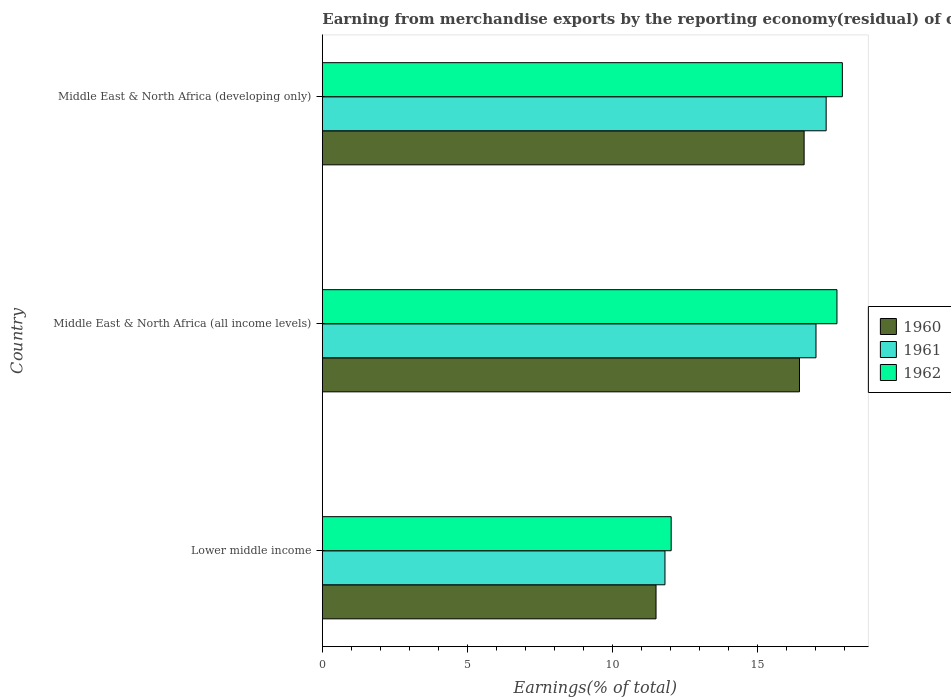How many different coloured bars are there?
Ensure brevity in your answer.  3. Are the number of bars per tick equal to the number of legend labels?
Your answer should be very brief. Yes. Are the number of bars on each tick of the Y-axis equal?
Keep it short and to the point. Yes. How many bars are there on the 2nd tick from the top?
Your answer should be very brief. 3. How many bars are there on the 3rd tick from the bottom?
Ensure brevity in your answer.  3. What is the label of the 3rd group of bars from the top?
Ensure brevity in your answer.  Lower middle income. In how many cases, is the number of bars for a given country not equal to the number of legend labels?
Your response must be concise. 0. What is the percentage of amount earned from merchandise exports in 1962 in Lower middle income?
Keep it short and to the point. 12.02. Across all countries, what is the maximum percentage of amount earned from merchandise exports in 1962?
Provide a short and direct response. 17.93. Across all countries, what is the minimum percentage of amount earned from merchandise exports in 1961?
Your answer should be very brief. 11.81. In which country was the percentage of amount earned from merchandise exports in 1962 maximum?
Your answer should be compact. Middle East & North Africa (developing only). In which country was the percentage of amount earned from merchandise exports in 1961 minimum?
Keep it short and to the point. Lower middle income. What is the total percentage of amount earned from merchandise exports in 1961 in the graph?
Ensure brevity in your answer.  46.19. What is the difference between the percentage of amount earned from merchandise exports in 1961 in Middle East & North Africa (all income levels) and that in Middle East & North Africa (developing only)?
Provide a short and direct response. -0.35. What is the difference between the percentage of amount earned from merchandise exports in 1960 in Lower middle income and the percentage of amount earned from merchandise exports in 1962 in Middle East & North Africa (all income levels)?
Provide a succinct answer. -6.24. What is the average percentage of amount earned from merchandise exports in 1960 per country?
Offer a very short reply. 14.85. What is the difference between the percentage of amount earned from merchandise exports in 1960 and percentage of amount earned from merchandise exports in 1962 in Middle East & North Africa (developing only)?
Offer a very short reply. -1.32. In how many countries, is the percentage of amount earned from merchandise exports in 1962 greater than 11 %?
Give a very brief answer. 3. What is the ratio of the percentage of amount earned from merchandise exports in 1962 in Middle East & North Africa (all income levels) to that in Middle East & North Africa (developing only)?
Offer a very short reply. 0.99. Is the difference between the percentage of amount earned from merchandise exports in 1960 in Middle East & North Africa (all income levels) and Middle East & North Africa (developing only) greater than the difference between the percentage of amount earned from merchandise exports in 1962 in Middle East & North Africa (all income levels) and Middle East & North Africa (developing only)?
Your response must be concise. Yes. What is the difference between the highest and the second highest percentage of amount earned from merchandise exports in 1961?
Your response must be concise. 0.35. What is the difference between the highest and the lowest percentage of amount earned from merchandise exports in 1961?
Give a very brief answer. 5.56. In how many countries, is the percentage of amount earned from merchandise exports in 1961 greater than the average percentage of amount earned from merchandise exports in 1961 taken over all countries?
Make the answer very short. 2. Is the sum of the percentage of amount earned from merchandise exports in 1961 in Lower middle income and Middle East & North Africa (developing only) greater than the maximum percentage of amount earned from merchandise exports in 1960 across all countries?
Keep it short and to the point. Yes. Is it the case that in every country, the sum of the percentage of amount earned from merchandise exports in 1961 and percentage of amount earned from merchandise exports in 1960 is greater than the percentage of amount earned from merchandise exports in 1962?
Your answer should be compact. Yes. Are all the bars in the graph horizontal?
Give a very brief answer. Yes. Are the values on the major ticks of X-axis written in scientific E-notation?
Offer a terse response. No. Where does the legend appear in the graph?
Give a very brief answer. Center right. What is the title of the graph?
Your answer should be compact. Earning from merchandise exports by the reporting economy(residual) of countries. Does "1989" appear as one of the legend labels in the graph?
Ensure brevity in your answer.  No. What is the label or title of the X-axis?
Your response must be concise. Earnings(% of total). What is the Earnings(% of total) of 1960 in Lower middle income?
Make the answer very short. 11.5. What is the Earnings(% of total) of 1961 in Lower middle income?
Ensure brevity in your answer.  11.81. What is the Earnings(% of total) of 1962 in Lower middle income?
Your response must be concise. 12.02. What is the Earnings(% of total) of 1960 in Middle East & North Africa (all income levels)?
Ensure brevity in your answer.  16.45. What is the Earnings(% of total) of 1961 in Middle East & North Africa (all income levels)?
Give a very brief answer. 17.02. What is the Earnings(% of total) in 1962 in Middle East & North Africa (all income levels)?
Keep it short and to the point. 17.74. What is the Earnings(% of total) in 1960 in Middle East & North Africa (developing only)?
Your answer should be compact. 16.61. What is the Earnings(% of total) in 1961 in Middle East & North Africa (developing only)?
Provide a succinct answer. 17.37. What is the Earnings(% of total) in 1962 in Middle East & North Africa (developing only)?
Your answer should be very brief. 17.93. Across all countries, what is the maximum Earnings(% of total) of 1960?
Your response must be concise. 16.61. Across all countries, what is the maximum Earnings(% of total) in 1961?
Your answer should be very brief. 17.37. Across all countries, what is the maximum Earnings(% of total) in 1962?
Ensure brevity in your answer.  17.93. Across all countries, what is the minimum Earnings(% of total) of 1960?
Offer a very short reply. 11.5. Across all countries, what is the minimum Earnings(% of total) in 1961?
Your answer should be very brief. 11.81. Across all countries, what is the minimum Earnings(% of total) of 1962?
Your answer should be very brief. 12.02. What is the total Earnings(% of total) in 1960 in the graph?
Provide a short and direct response. 44.56. What is the total Earnings(% of total) of 1961 in the graph?
Make the answer very short. 46.19. What is the total Earnings(% of total) in 1962 in the graph?
Give a very brief answer. 47.69. What is the difference between the Earnings(% of total) in 1960 in Lower middle income and that in Middle East & North Africa (all income levels)?
Offer a very short reply. -4.94. What is the difference between the Earnings(% of total) in 1961 in Lower middle income and that in Middle East & North Africa (all income levels)?
Your answer should be very brief. -5.21. What is the difference between the Earnings(% of total) of 1962 in Lower middle income and that in Middle East & North Africa (all income levels)?
Offer a very short reply. -5.71. What is the difference between the Earnings(% of total) in 1960 in Lower middle income and that in Middle East & North Africa (developing only)?
Offer a very short reply. -5.1. What is the difference between the Earnings(% of total) in 1961 in Lower middle income and that in Middle East & North Africa (developing only)?
Keep it short and to the point. -5.56. What is the difference between the Earnings(% of total) of 1962 in Lower middle income and that in Middle East & North Africa (developing only)?
Provide a succinct answer. -5.9. What is the difference between the Earnings(% of total) of 1960 in Middle East & North Africa (all income levels) and that in Middle East & North Africa (developing only)?
Keep it short and to the point. -0.16. What is the difference between the Earnings(% of total) of 1961 in Middle East & North Africa (all income levels) and that in Middle East & North Africa (developing only)?
Your response must be concise. -0.35. What is the difference between the Earnings(% of total) of 1962 in Middle East & North Africa (all income levels) and that in Middle East & North Africa (developing only)?
Your answer should be very brief. -0.19. What is the difference between the Earnings(% of total) in 1960 in Lower middle income and the Earnings(% of total) in 1961 in Middle East & North Africa (all income levels)?
Your answer should be compact. -5.51. What is the difference between the Earnings(% of total) of 1960 in Lower middle income and the Earnings(% of total) of 1962 in Middle East & North Africa (all income levels)?
Provide a short and direct response. -6.24. What is the difference between the Earnings(% of total) of 1961 in Lower middle income and the Earnings(% of total) of 1962 in Middle East & North Africa (all income levels)?
Ensure brevity in your answer.  -5.93. What is the difference between the Earnings(% of total) in 1960 in Lower middle income and the Earnings(% of total) in 1961 in Middle East & North Africa (developing only)?
Your answer should be very brief. -5.86. What is the difference between the Earnings(% of total) of 1960 in Lower middle income and the Earnings(% of total) of 1962 in Middle East & North Africa (developing only)?
Your response must be concise. -6.42. What is the difference between the Earnings(% of total) of 1961 in Lower middle income and the Earnings(% of total) of 1962 in Middle East & North Africa (developing only)?
Your response must be concise. -6.11. What is the difference between the Earnings(% of total) in 1960 in Middle East & North Africa (all income levels) and the Earnings(% of total) in 1961 in Middle East & North Africa (developing only)?
Provide a short and direct response. -0.92. What is the difference between the Earnings(% of total) in 1960 in Middle East & North Africa (all income levels) and the Earnings(% of total) in 1962 in Middle East & North Africa (developing only)?
Your answer should be compact. -1.48. What is the difference between the Earnings(% of total) of 1961 in Middle East & North Africa (all income levels) and the Earnings(% of total) of 1962 in Middle East & North Africa (developing only)?
Offer a very short reply. -0.91. What is the average Earnings(% of total) in 1960 per country?
Offer a terse response. 14.85. What is the average Earnings(% of total) in 1961 per country?
Your answer should be compact. 15.4. What is the average Earnings(% of total) of 1962 per country?
Offer a terse response. 15.9. What is the difference between the Earnings(% of total) in 1960 and Earnings(% of total) in 1961 in Lower middle income?
Provide a short and direct response. -0.31. What is the difference between the Earnings(% of total) of 1960 and Earnings(% of total) of 1962 in Lower middle income?
Give a very brief answer. -0.52. What is the difference between the Earnings(% of total) in 1961 and Earnings(% of total) in 1962 in Lower middle income?
Provide a succinct answer. -0.21. What is the difference between the Earnings(% of total) in 1960 and Earnings(% of total) in 1961 in Middle East & North Africa (all income levels)?
Give a very brief answer. -0.57. What is the difference between the Earnings(% of total) in 1960 and Earnings(% of total) in 1962 in Middle East & North Africa (all income levels)?
Keep it short and to the point. -1.29. What is the difference between the Earnings(% of total) of 1961 and Earnings(% of total) of 1962 in Middle East & North Africa (all income levels)?
Offer a terse response. -0.72. What is the difference between the Earnings(% of total) in 1960 and Earnings(% of total) in 1961 in Middle East & North Africa (developing only)?
Give a very brief answer. -0.76. What is the difference between the Earnings(% of total) of 1960 and Earnings(% of total) of 1962 in Middle East & North Africa (developing only)?
Give a very brief answer. -1.32. What is the difference between the Earnings(% of total) of 1961 and Earnings(% of total) of 1962 in Middle East & North Africa (developing only)?
Your answer should be compact. -0.56. What is the ratio of the Earnings(% of total) of 1960 in Lower middle income to that in Middle East & North Africa (all income levels)?
Your response must be concise. 0.7. What is the ratio of the Earnings(% of total) of 1961 in Lower middle income to that in Middle East & North Africa (all income levels)?
Offer a terse response. 0.69. What is the ratio of the Earnings(% of total) of 1962 in Lower middle income to that in Middle East & North Africa (all income levels)?
Your answer should be compact. 0.68. What is the ratio of the Earnings(% of total) in 1960 in Lower middle income to that in Middle East & North Africa (developing only)?
Provide a succinct answer. 0.69. What is the ratio of the Earnings(% of total) in 1961 in Lower middle income to that in Middle East & North Africa (developing only)?
Provide a succinct answer. 0.68. What is the ratio of the Earnings(% of total) of 1962 in Lower middle income to that in Middle East & North Africa (developing only)?
Give a very brief answer. 0.67. What is the ratio of the Earnings(% of total) of 1961 in Middle East & North Africa (all income levels) to that in Middle East & North Africa (developing only)?
Keep it short and to the point. 0.98. What is the ratio of the Earnings(% of total) of 1962 in Middle East & North Africa (all income levels) to that in Middle East & North Africa (developing only)?
Ensure brevity in your answer.  0.99. What is the difference between the highest and the second highest Earnings(% of total) in 1960?
Offer a very short reply. 0.16. What is the difference between the highest and the second highest Earnings(% of total) in 1961?
Your response must be concise. 0.35. What is the difference between the highest and the second highest Earnings(% of total) in 1962?
Provide a succinct answer. 0.19. What is the difference between the highest and the lowest Earnings(% of total) in 1960?
Make the answer very short. 5.1. What is the difference between the highest and the lowest Earnings(% of total) in 1961?
Your answer should be very brief. 5.56. What is the difference between the highest and the lowest Earnings(% of total) in 1962?
Provide a succinct answer. 5.9. 